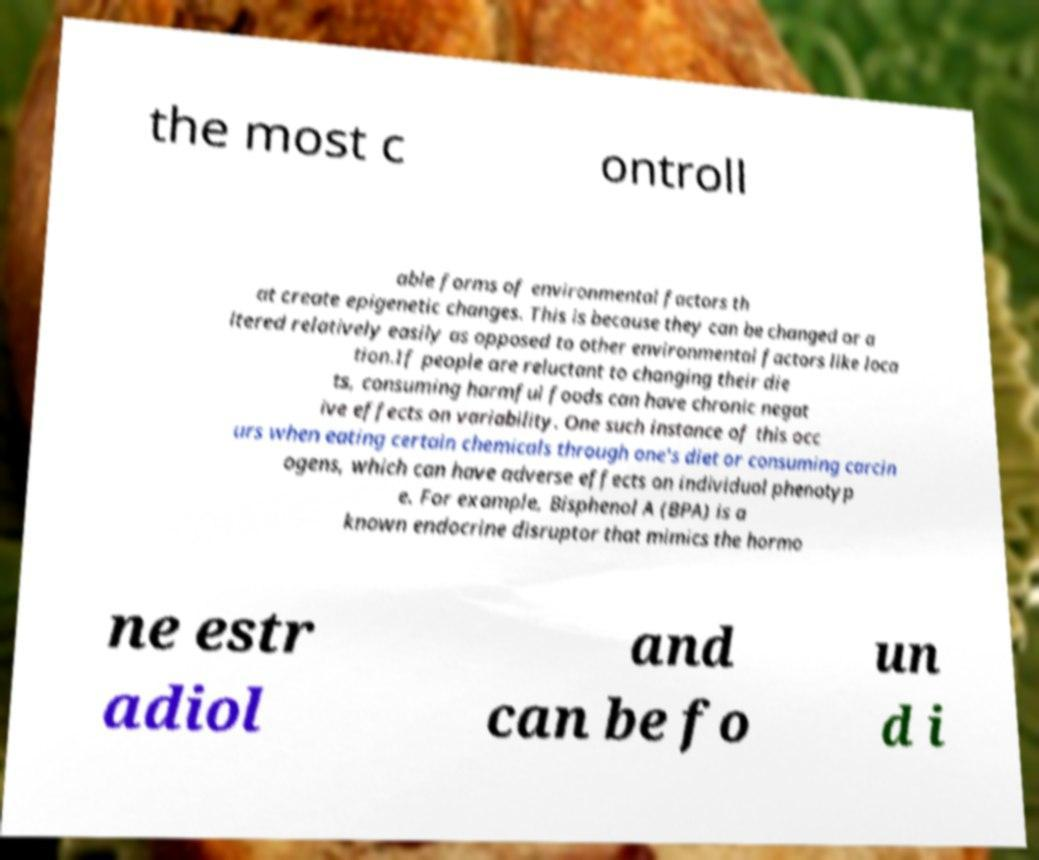For documentation purposes, I need the text within this image transcribed. Could you provide that? the most c ontroll able forms of environmental factors th at create epigenetic changes. This is because they can be changed or a ltered relatively easily as opposed to other environmental factors like loca tion.If people are reluctant to changing their die ts, consuming harmful foods can have chronic negat ive effects on variability. One such instance of this occ urs when eating certain chemicals through one's diet or consuming carcin ogens, which can have adverse effects on individual phenotyp e. For example, Bisphenol A (BPA) is a known endocrine disruptor that mimics the hormo ne estr adiol and can be fo un d i 